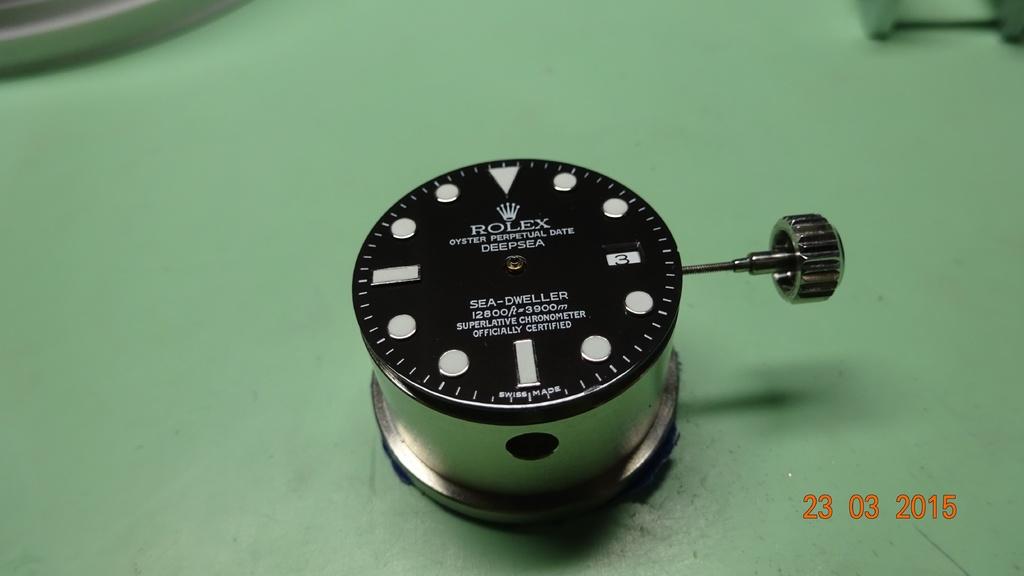What company is the product by?
Make the answer very short. Rolex. What is the date on this photo?
Provide a succinct answer. 23 03 2015. 